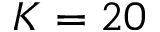<formula> <loc_0><loc_0><loc_500><loc_500>K = 2 0</formula> 